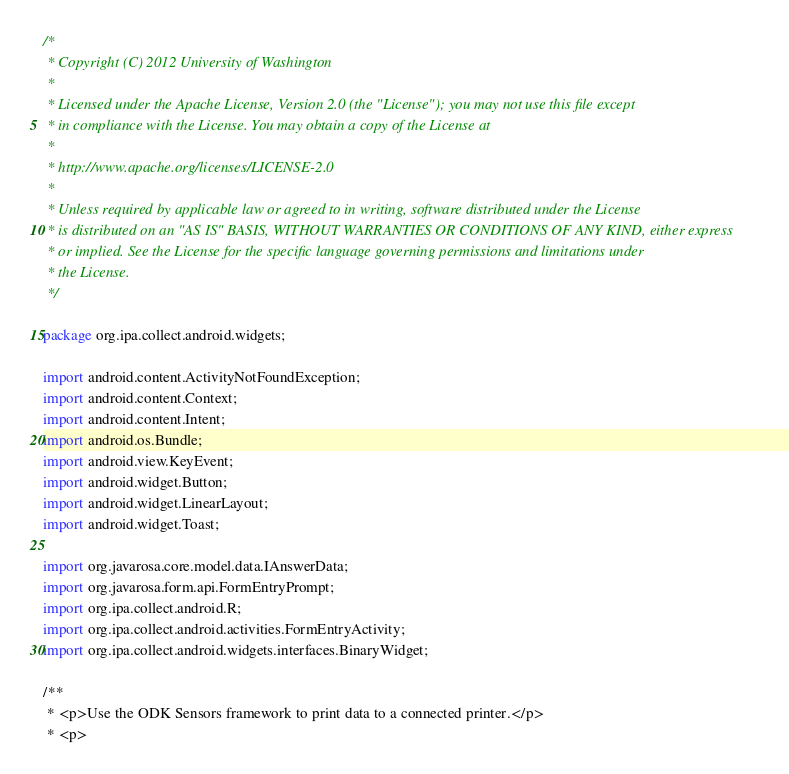<code> <loc_0><loc_0><loc_500><loc_500><_Java_>/*
 * Copyright (C) 2012 University of Washington
 *
 * Licensed under the Apache License, Version 2.0 (the "License"); you may not use this file except
 * in compliance with the License. You may obtain a copy of the License at
 *
 * http://www.apache.org/licenses/LICENSE-2.0
 *
 * Unless required by applicable law or agreed to in writing, software distributed under the License
 * is distributed on an "AS IS" BASIS, WITHOUT WARRANTIES OR CONDITIONS OF ANY KIND, either express
 * or implied. See the License for the specific language governing permissions and limitations under
 * the License.
 */

package org.ipa.collect.android.widgets;

import android.content.ActivityNotFoundException;
import android.content.Context;
import android.content.Intent;
import android.os.Bundle;
import android.view.KeyEvent;
import android.widget.Button;
import android.widget.LinearLayout;
import android.widget.Toast;

import org.javarosa.core.model.data.IAnswerData;
import org.javarosa.form.api.FormEntryPrompt;
import org.ipa.collect.android.R;
import org.ipa.collect.android.activities.FormEntryActivity;
import org.ipa.collect.android.widgets.interfaces.BinaryWidget;

/**
 * <p>Use the ODK Sensors framework to print data to a connected printer.</p>
 * <p></code> 